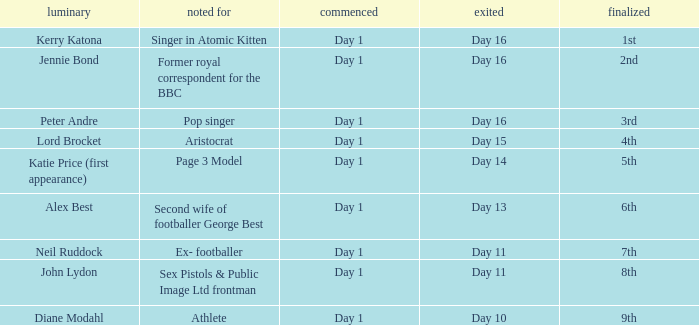Name the finished for exited day 13 6th. 